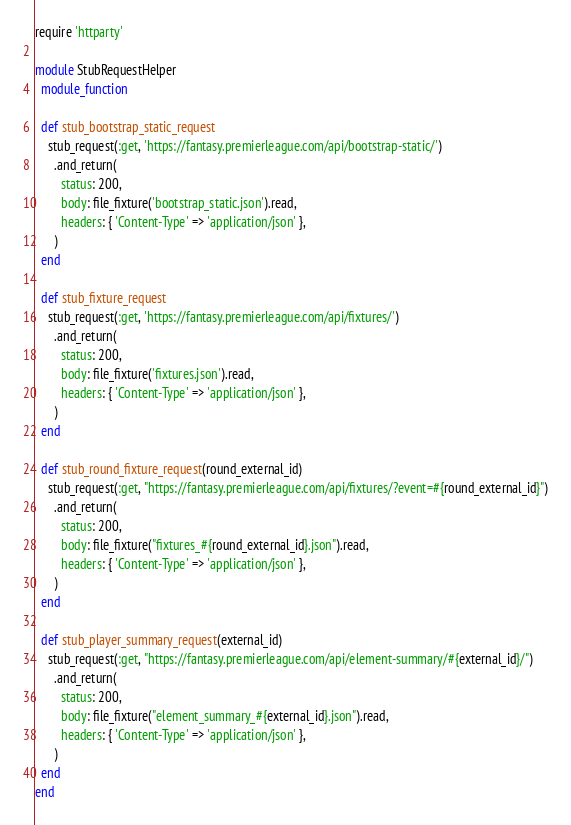Convert code to text. <code><loc_0><loc_0><loc_500><loc_500><_Ruby_>require 'httparty'

module StubRequestHelper
  module_function

  def stub_bootstrap_static_request
    stub_request(:get, 'https://fantasy.premierleague.com/api/bootstrap-static/')
      .and_return(
        status: 200,
        body: file_fixture('bootstrap_static.json').read,
        headers: { 'Content-Type' => 'application/json' },
      )
  end

  def stub_fixture_request
    stub_request(:get, 'https://fantasy.premierleague.com/api/fixtures/')
      .and_return(
        status: 200,
        body: file_fixture('fixtures.json').read,
        headers: { 'Content-Type' => 'application/json' },
      )
  end

  def stub_round_fixture_request(round_external_id)
    stub_request(:get, "https://fantasy.premierleague.com/api/fixtures/?event=#{round_external_id}")
      .and_return(
        status: 200,
        body: file_fixture("fixtures_#{round_external_id}.json").read,
        headers: { 'Content-Type' => 'application/json' },
      )
  end

  def stub_player_summary_request(external_id)
    stub_request(:get, "https://fantasy.premierleague.com/api/element-summary/#{external_id}/")
      .and_return(
        status: 200,
        body: file_fixture("element_summary_#{external_id}.json").read,
        headers: { 'Content-Type' => 'application/json' },
      )
  end
end
</code> 